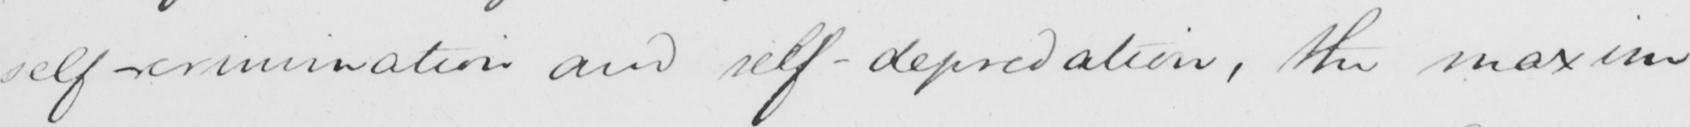Transcribe the text shown in this historical manuscript line. self-crimination and self-depredation , the maxim 